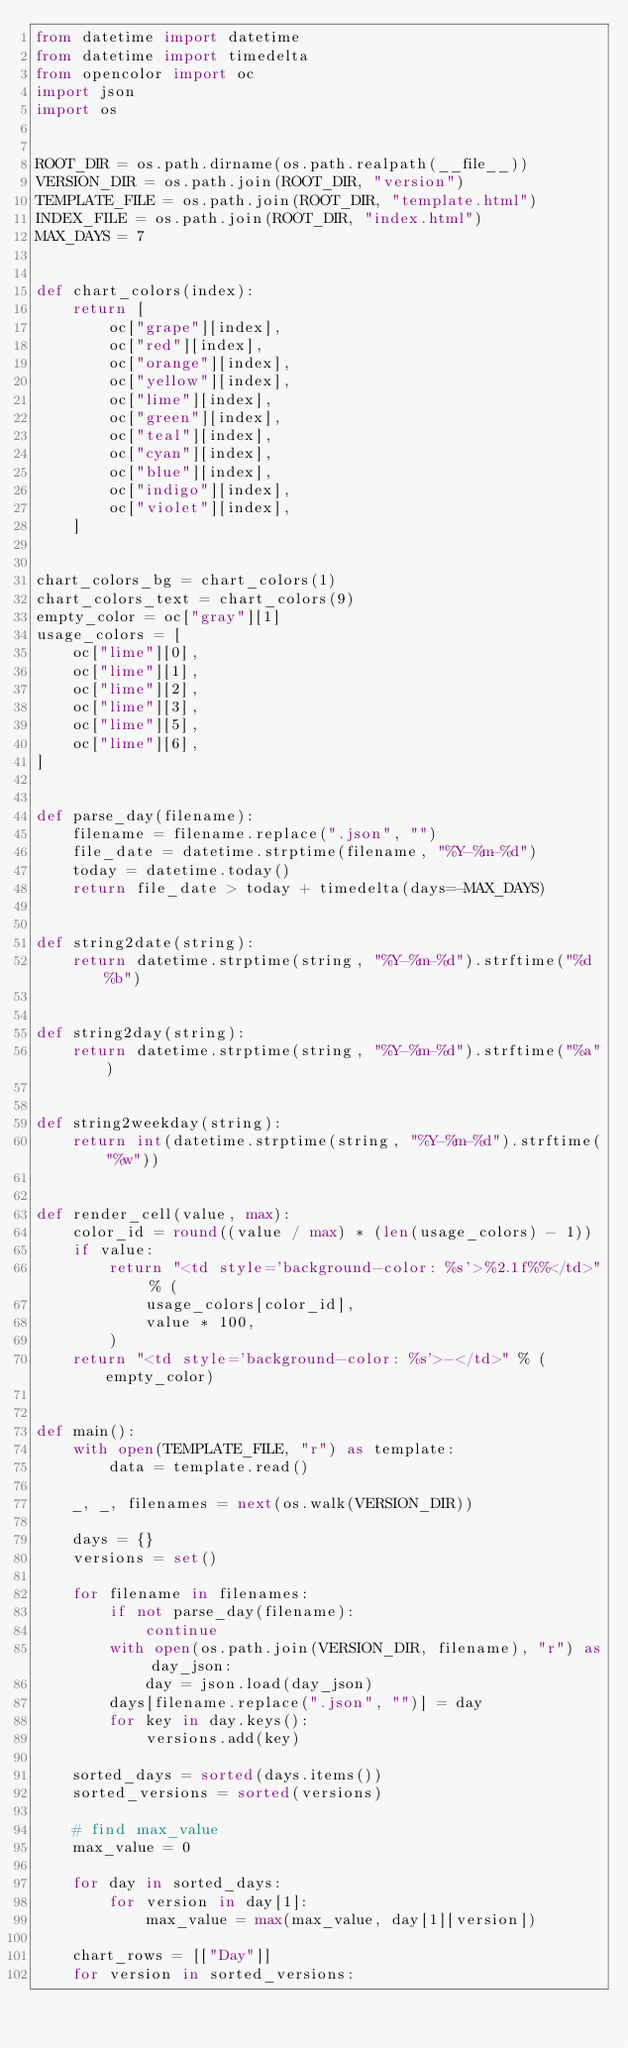Convert code to text. <code><loc_0><loc_0><loc_500><loc_500><_Python_>from datetime import datetime
from datetime import timedelta
from opencolor import oc
import json
import os


ROOT_DIR = os.path.dirname(os.path.realpath(__file__))
VERSION_DIR = os.path.join(ROOT_DIR, "version")
TEMPLATE_FILE = os.path.join(ROOT_DIR, "template.html")
INDEX_FILE = os.path.join(ROOT_DIR, "index.html")
MAX_DAYS = 7


def chart_colors(index):
    return [
        oc["grape"][index],
        oc["red"][index],
        oc["orange"][index],
        oc["yellow"][index],
        oc["lime"][index],
        oc["green"][index],
        oc["teal"][index],
        oc["cyan"][index],
        oc["blue"][index],
        oc["indigo"][index],
        oc["violet"][index],
    ]


chart_colors_bg = chart_colors(1)
chart_colors_text = chart_colors(9)
empty_color = oc["gray"][1]
usage_colors = [
    oc["lime"][0],
    oc["lime"][1],
    oc["lime"][2],
    oc["lime"][3],
    oc["lime"][5],
    oc["lime"][6],
]


def parse_day(filename):
    filename = filename.replace(".json", "")
    file_date = datetime.strptime(filename, "%Y-%m-%d")
    today = datetime.today()
    return file_date > today + timedelta(days=-MAX_DAYS)


def string2date(string):
    return datetime.strptime(string, "%Y-%m-%d").strftime("%d %b")


def string2day(string):
    return datetime.strptime(string, "%Y-%m-%d").strftime("%a")


def string2weekday(string):
    return int(datetime.strptime(string, "%Y-%m-%d").strftime("%w"))


def render_cell(value, max):
    color_id = round((value / max) * (len(usage_colors) - 1))
    if value:
        return "<td style='background-color: %s'>%2.1f%%</td>" % (
            usage_colors[color_id],
            value * 100,
        )
    return "<td style='background-color: %s'>-</td>" % (empty_color)


def main():
    with open(TEMPLATE_FILE, "r") as template:
        data = template.read()

    _, _, filenames = next(os.walk(VERSION_DIR))

    days = {}
    versions = set()

    for filename in filenames:
        if not parse_day(filename):
            continue
        with open(os.path.join(VERSION_DIR, filename), "r") as day_json:
            day = json.load(day_json)
        days[filename.replace(".json", "")] = day
        for key in day.keys():
            versions.add(key)

    sorted_days = sorted(days.items())
    sorted_versions = sorted(versions)

    # find max_value
    max_value = 0

    for day in sorted_days:
        for version in day[1]:
            max_value = max(max_value, day[1][version])

    chart_rows = [["Day"]]
    for version in sorted_versions:</code> 